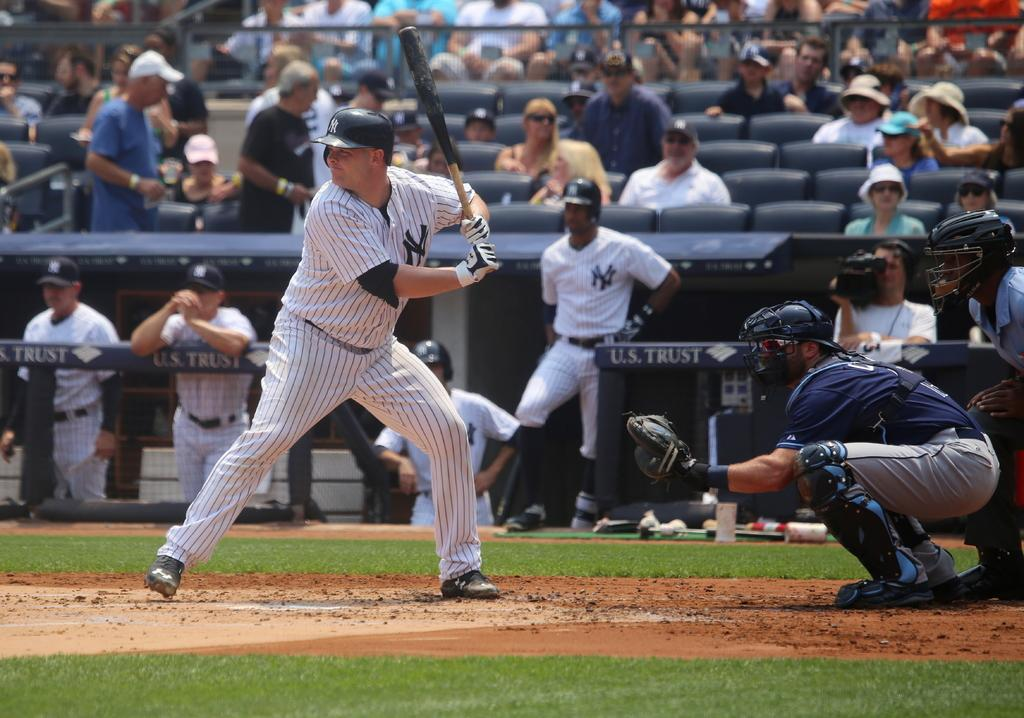<image>
Offer a succinct explanation of the picture presented. Baseball player getting ready to bat in front of a fence that says "U.S. Trust" on top. 